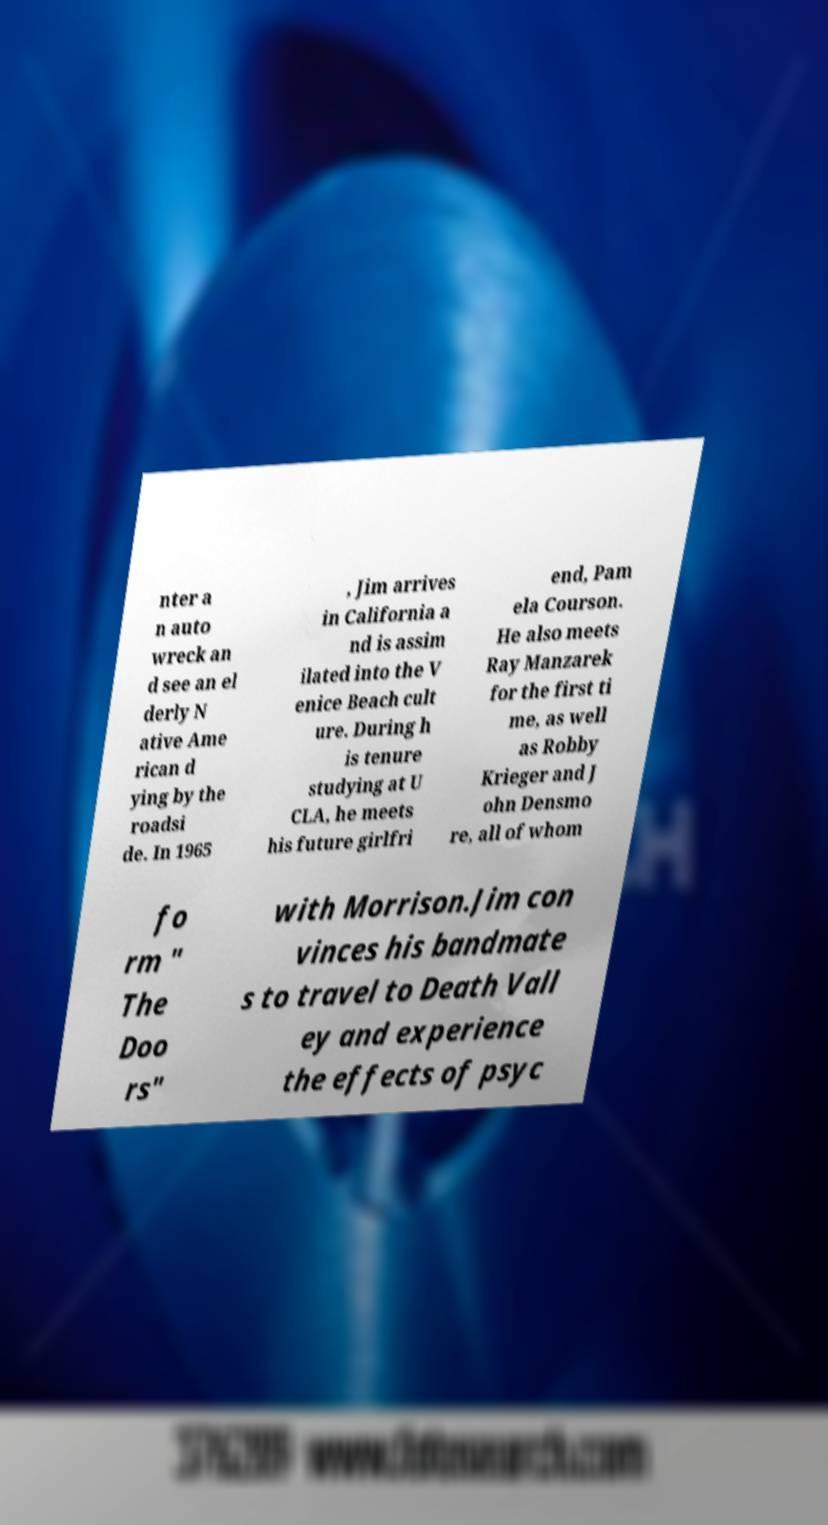Could you assist in decoding the text presented in this image and type it out clearly? nter a n auto wreck an d see an el derly N ative Ame rican d ying by the roadsi de. In 1965 , Jim arrives in California a nd is assim ilated into the V enice Beach cult ure. During h is tenure studying at U CLA, he meets his future girlfri end, Pam ela Courson. He also meets Ray Manzarek for the first ti me, as well as Robby Krieger and J ohn Densmo re, all of whom fo rm " The Doo rs" with Morrison.Jim con vinces his bandmate s to travel to Death Vall ey and experience the effects of psyc 